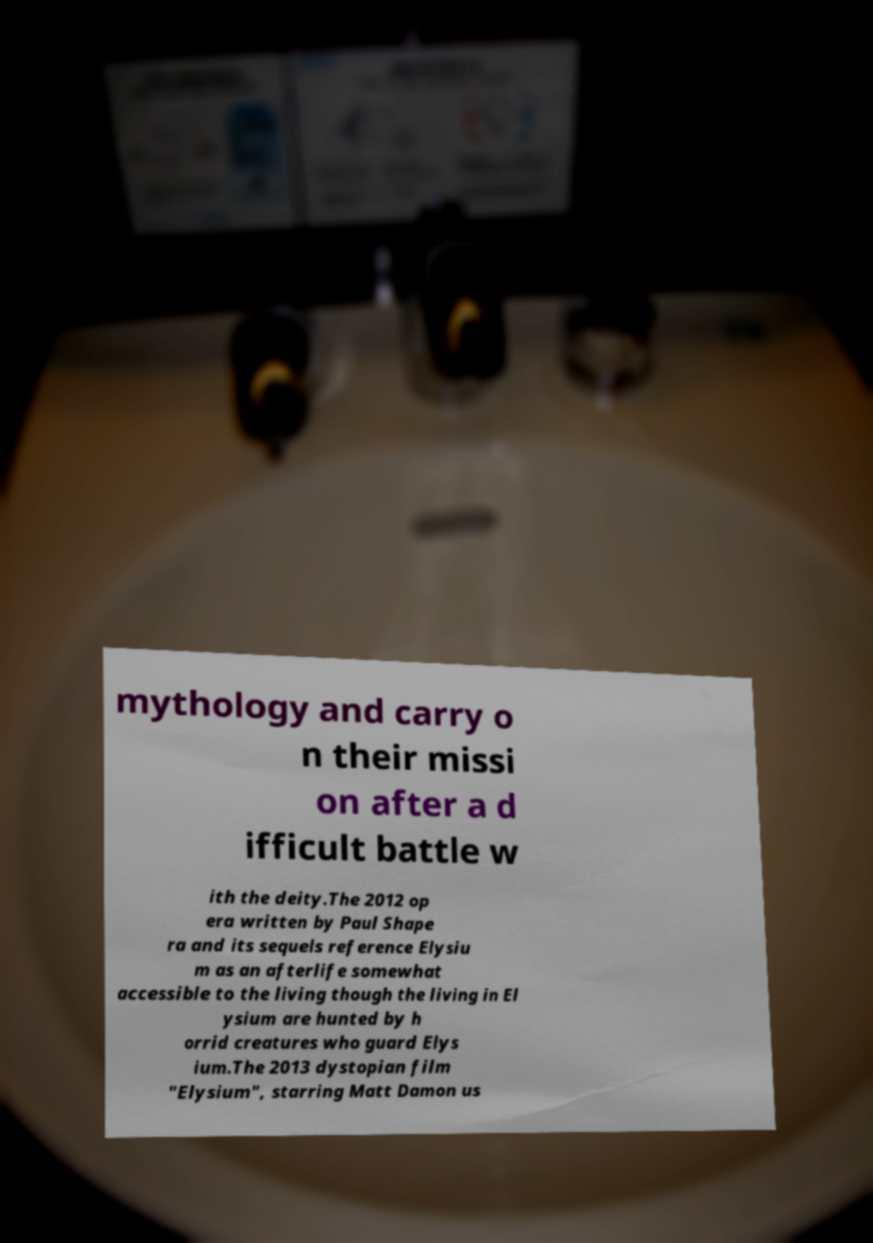There's text embedded in this image that I need extracted. Can you transcribe it verbatim? mythology and carry o n their missi on after a d ifficult battle w ith the deity.The 2012 op era written by Paul Shape ra and its sequels reference Elysiu m as an afterlife somewhat accessible to the living though the living in El ysium are hunted by h orrid creatures who guard Elys ium.The 2013 dystopian film "Elysium", starring Matt Damon us 